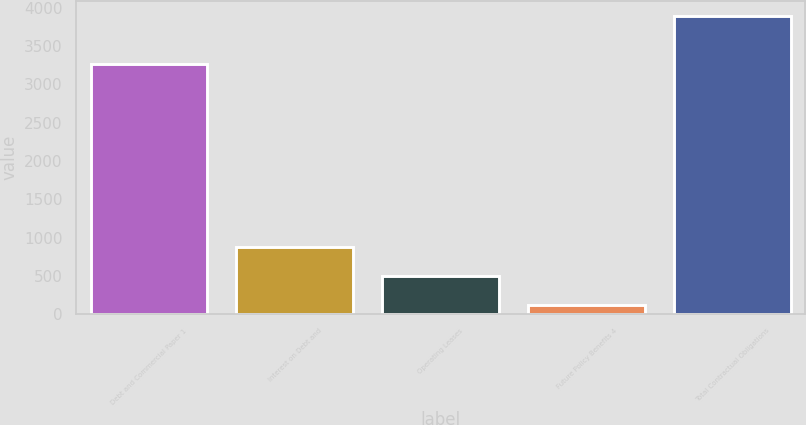Convert chart to OTSL. <chart><loc_0><loc_0><loc_500><loc_500><bar_chart><fcel>Debt and Commercial Paper 1<fcel>Interest on Debt and<fcel>Operating Leases<fcel>Future Policy Benefits 4<fcel>Total Contractual Obligations<nl><fcel>3261<fcel>874.6<fcel>497.3<fcel>120<fcel>3893<nl></chart> 